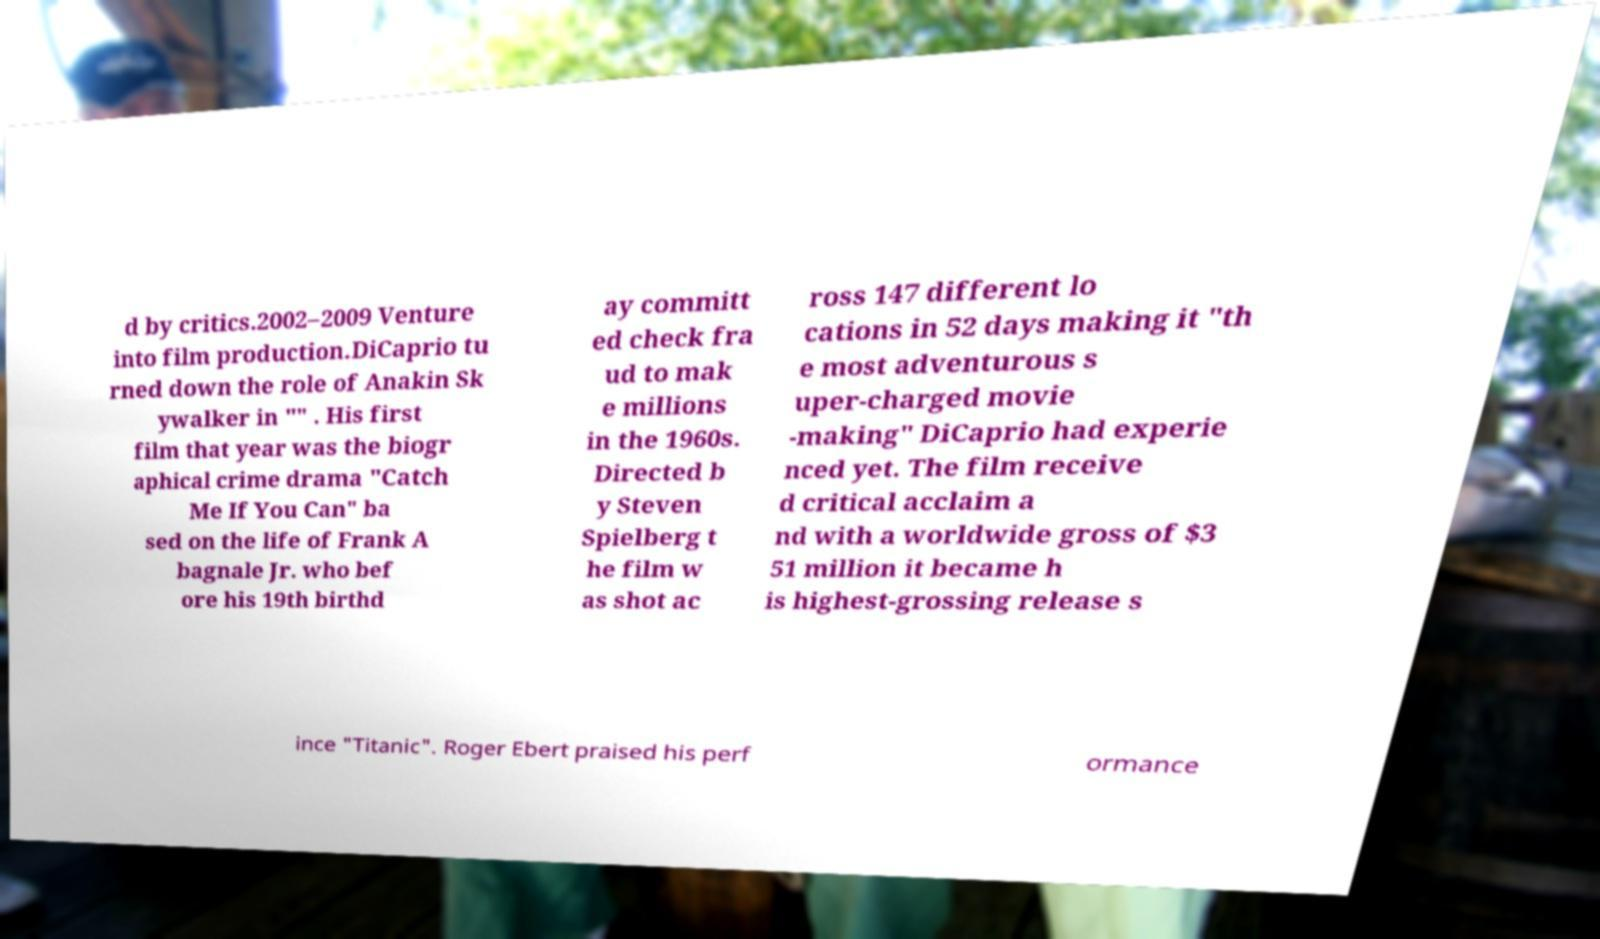Could you assist in decoding the text presented in this image and type it out clearly? d by critics.2002–2009 Venture into film production.DiCaprio tu rned down the role of Anakin Sk ywalker in "" . His first film that year was the biogr aphical crime drama "Catch Me If You Can" ba sed on the life of Frank A bagnale Jr. who bef ore his 19th birthd ay committ ed check fra ud to mak e millions in the 1960s. Directed b y Steven Spielberg t he film w as shot ac ross 147 different lo cations in 52 days making it "th e most adventurous s uper-charged movie -making" DiCaprio had experie nced yet. The film receive d critical acclaim a nd with a worldwide gross of $3 51 million it became h is highest-grossing release s ince "Titanic". Roger Ebert praised his perf ormance 